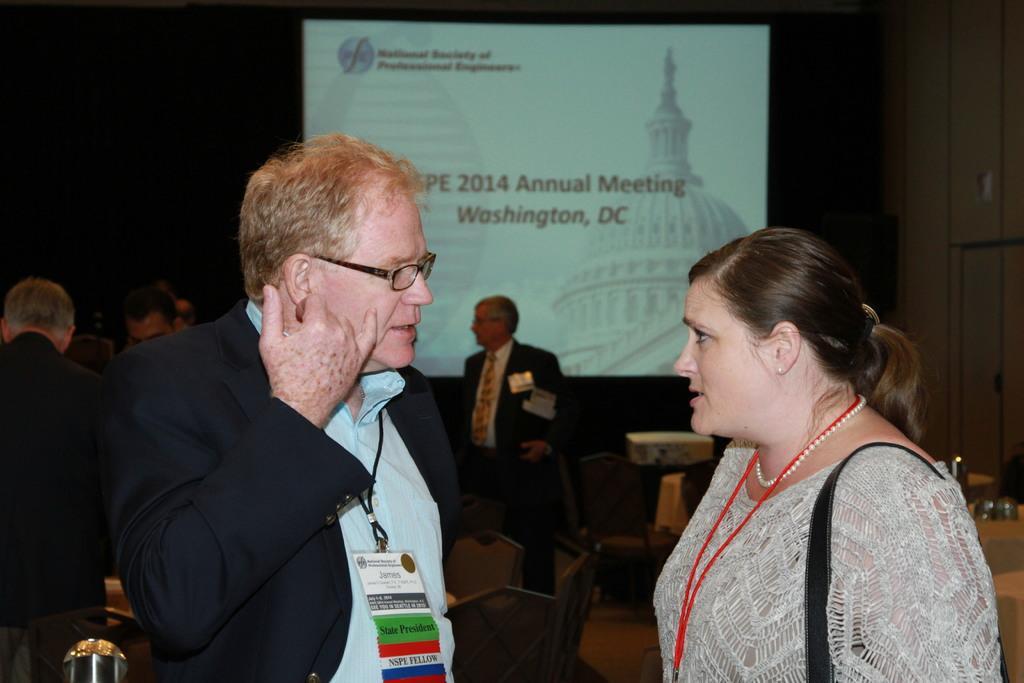Describe this image in one or two sentences. In this image we can see persons standing on the floor and chairs between them. In the background we can see wall and a display on it. 